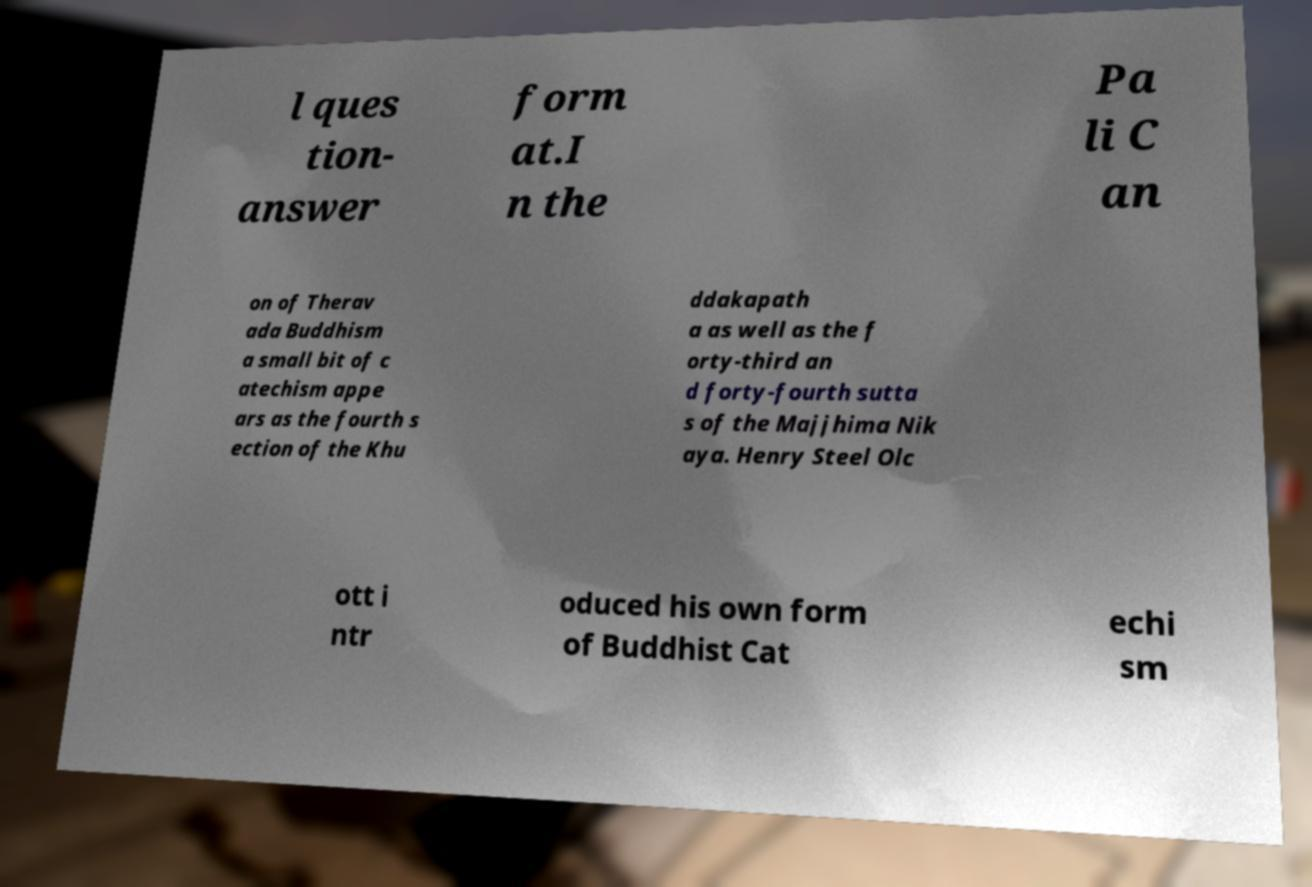Can you read and provide the text displayed in the image?This photo seems to have some interesting text. Can you extract and type it out for me? l ques tion- answer form at.I n the Pa li C an on of Therav ada Buddhism a small bit of c atechism appe ars as the fourth s ection of the Khu ddakapath a as well as the f orty-third an d forty-fourth sutta s of the Majjhima Nik aya. Henry Steel Olc ott i ntr oduced his own form of Buddhist Cat echi sm 